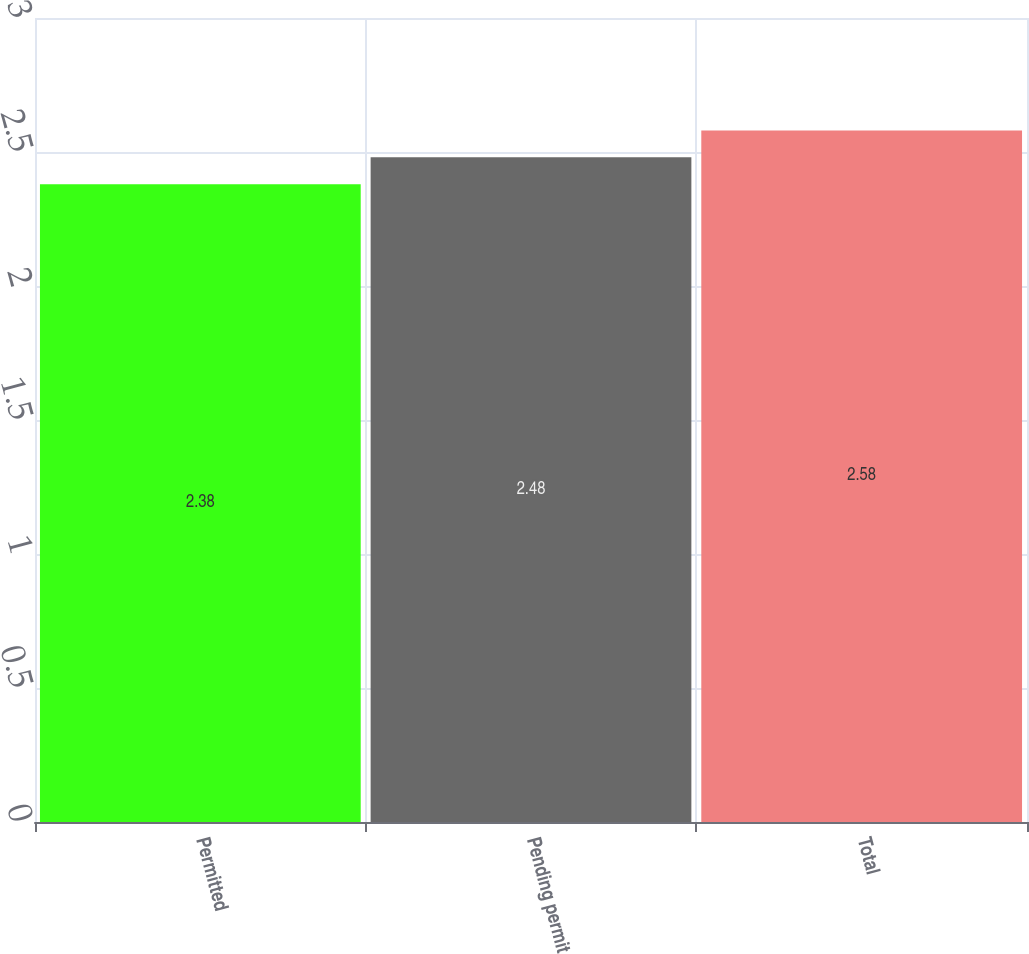Convert chart. <chart><loc_0><loc_0><loc_500><loc_500><bar_chart><fcel>Permitted<fcel>Pending permit<fcel>Total<nl><fcel>2.38<fcel>2.48<fcel>2.58<nl></chart> 